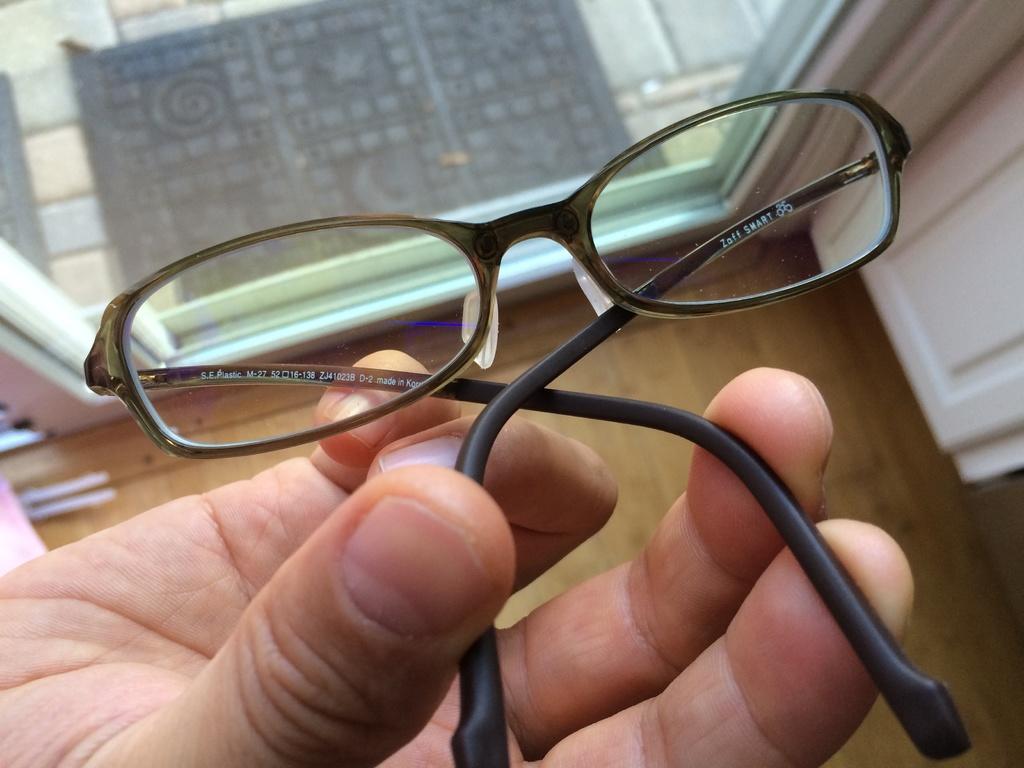Please provide a concise description of this image. In the image there is a person holding glasses, in the front there is a glass door and with behind it on the floor and below its wooden floor. 